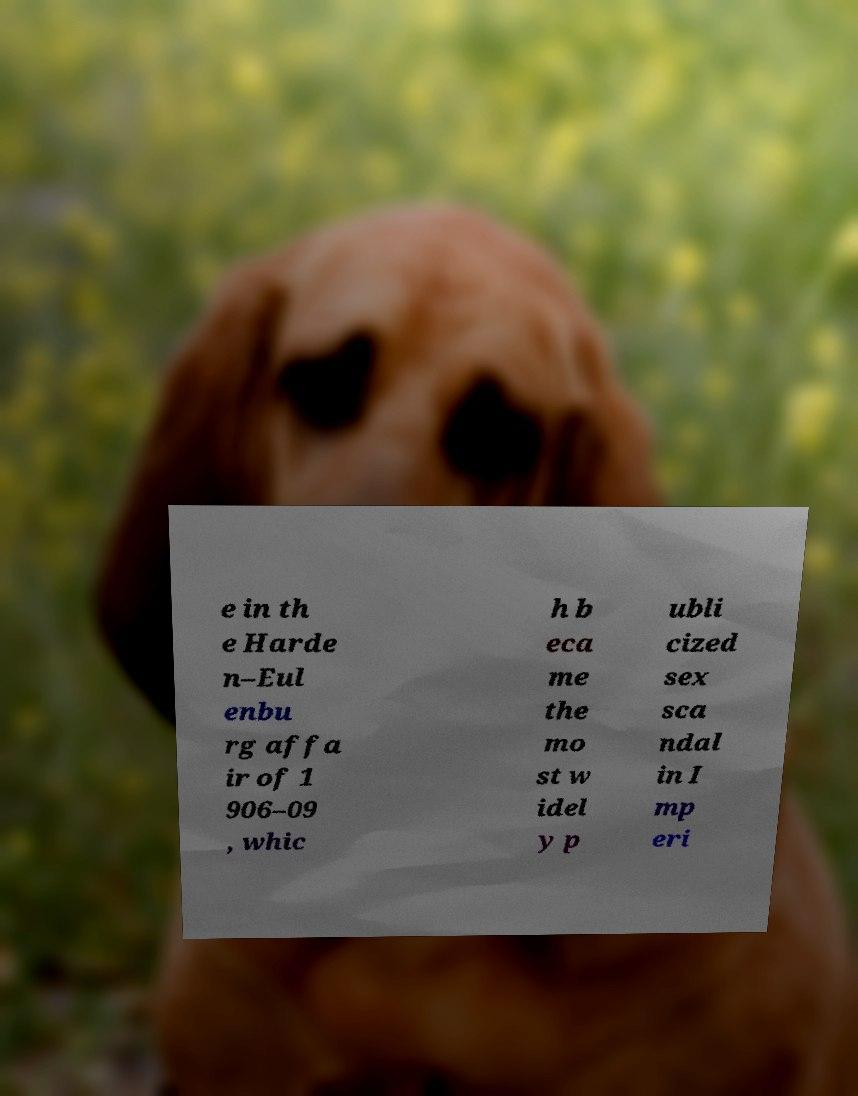For documentation purposes, I need the text within this image transcribed. Could you provide that? e in th e Harde n–Eul enbu rg affa ir of 1 906–09 , whic h b eca me the mo st w idel y p ubli cized sex sca ndal in I mp eri 